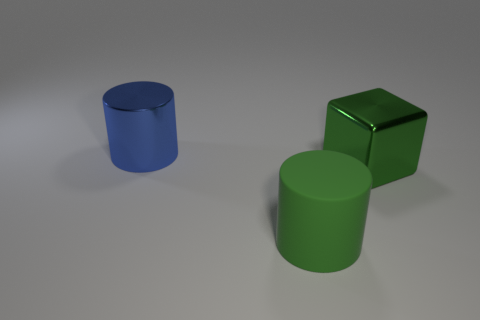Are the big blue object and the large cylinder in front of the big blue object made of the same material?
Provide a succinct answer. No. There is another object that is the same shape as the large blue object; what is it made of?
Give a very brief answer. Rubber. Are there any other things that have the same material as the green cylinder?
Ensure brevity in your answer.  No. Is the number of big blue cylinders that are left of the large green block greater than the number of shiny cylinders left of the big blue thing?
Your answer should be very brief. Yes. There is another thing that is the same material as the blue thing; what is its shape?
Provide a succinct answer. Cube. How many other objects are the same shape as the big green metallic thing?
Your answer should be very brief. 0. There is a large matte object that is in front of the blue shiny thing; what shape is it?
Your answer should be compact. Cylinder. What is the color of the matte cylinder?
Provide a short and direct response. Green. What number of other objects are there of the same size as the blue shiny object?
Provide a succinct answer. 2. What is the green object that is behind the cylinder that is in front of the big block made of?
Offer a terse response. Metal. 